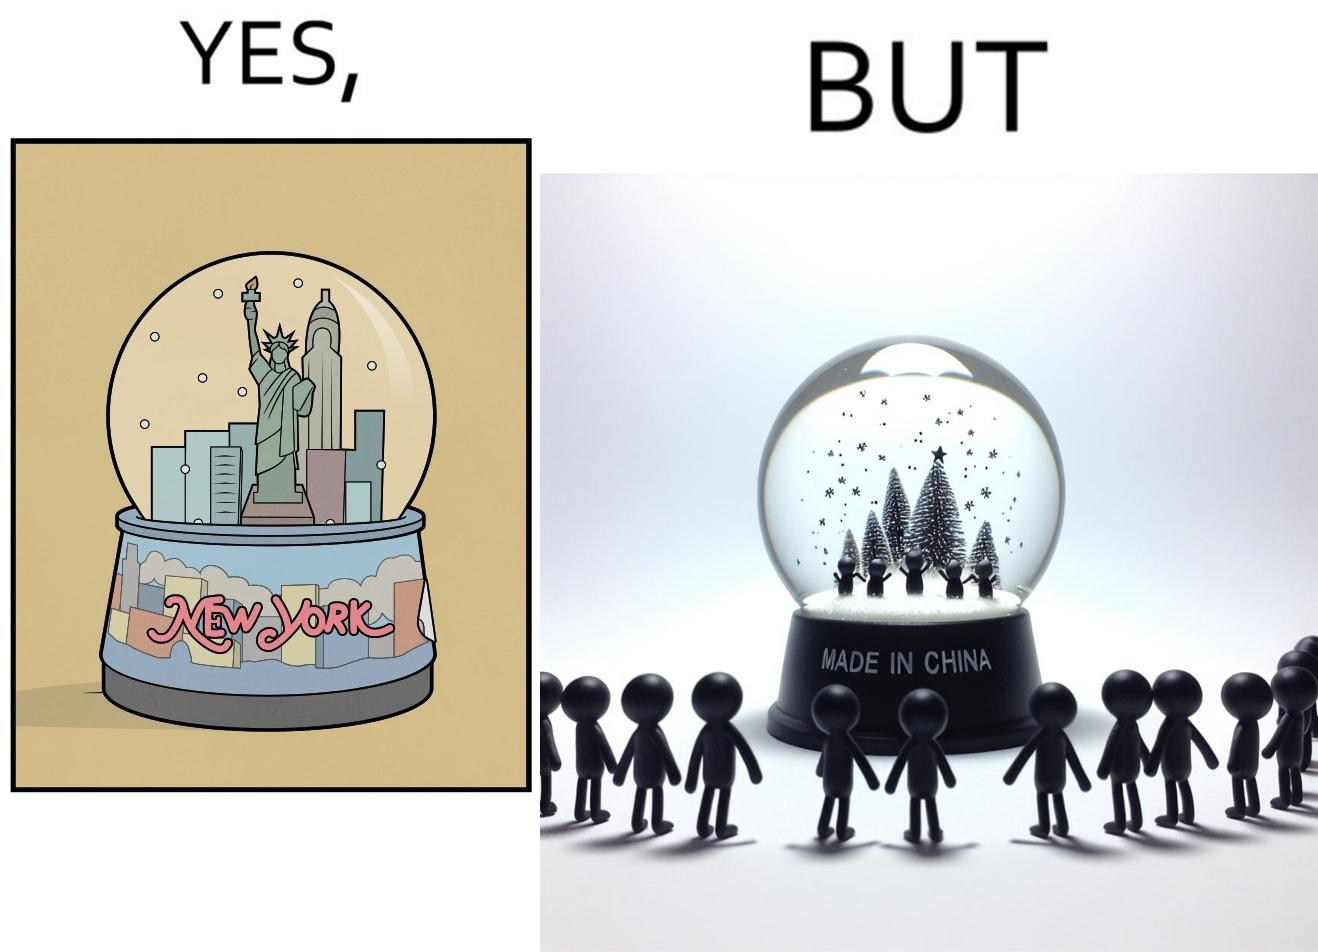Compare the left and right sides of this image. In the left part of the image: A snowglobe that says 'New York' In the right part of the image: Made in china' label on the snowglobe 